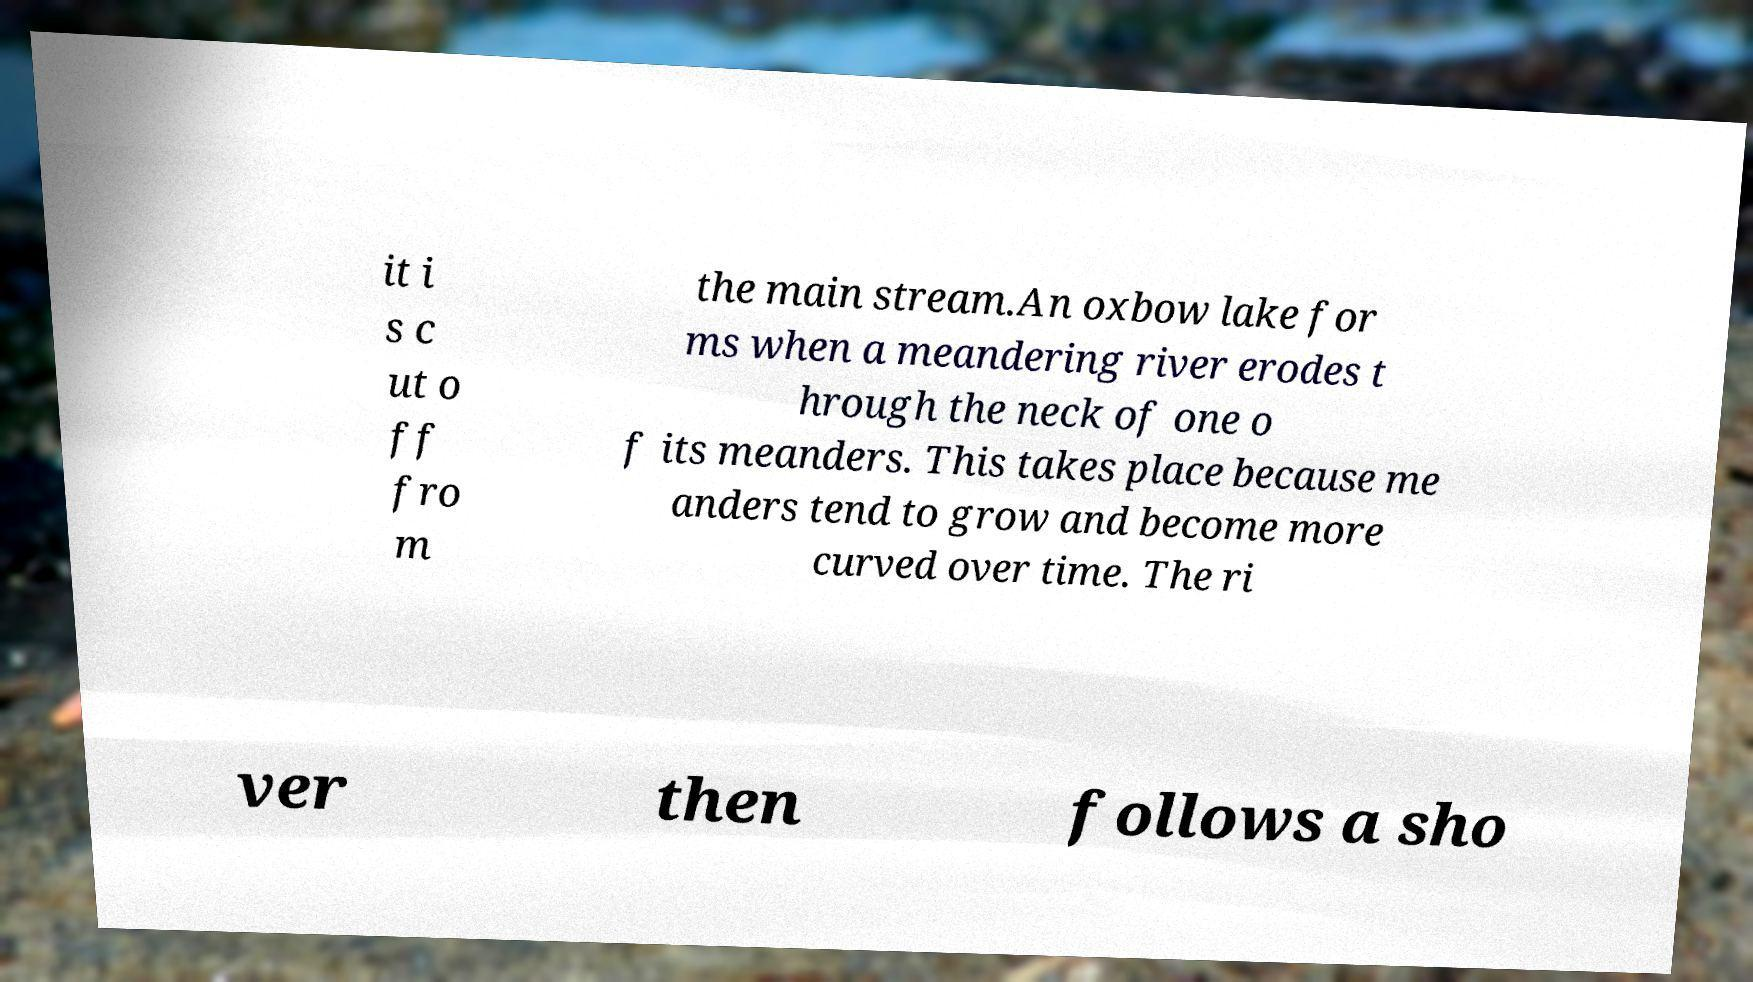Could you extract and type out the text from this image? it i s c ut o ff fro m the main stream.An oxbow lake for ms when a meandering river erodes t hrough the neck of one o f its meanders. This takes place because me anders tend to grow and become more curved over time. The ri ver then follows a sho 